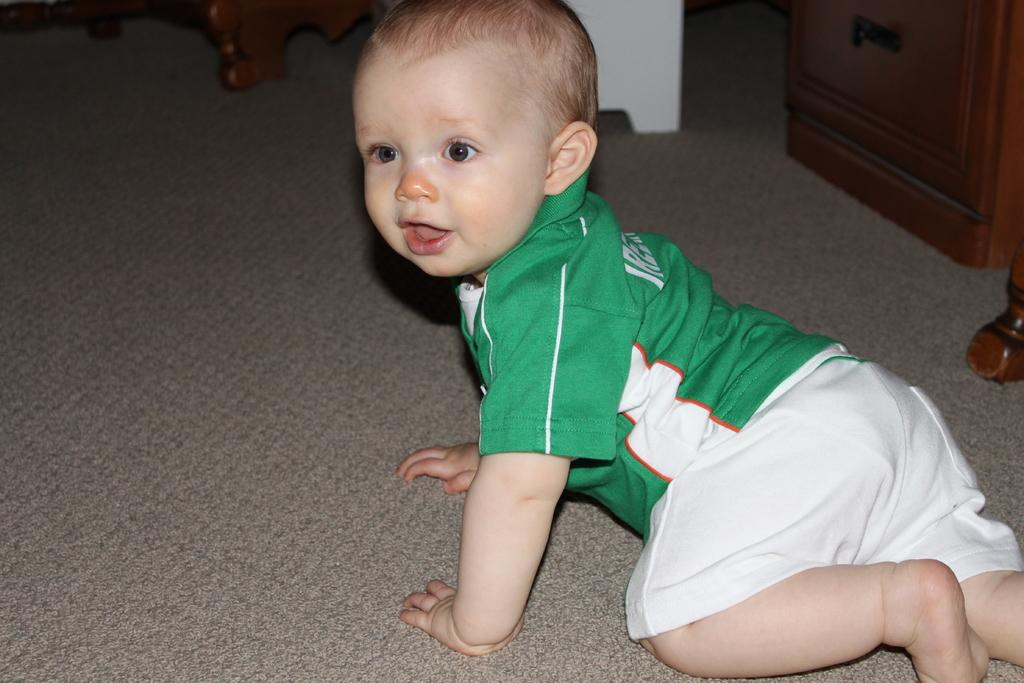What is the main subject of the image? There is a baby in the image. What is the baby doing in the image? The baby is crawling on a carpet. What type of flooring is visible in the image? The baby is crawling on a carpet. What can be seen at the top of the image? There are wooden objects at the top of the image. How many pizzas are being delivered to the baby in the image? There are no pizzas present in the image. What direction is the baby facing in the image? The image does not provide information about the direction the baby is facing. 